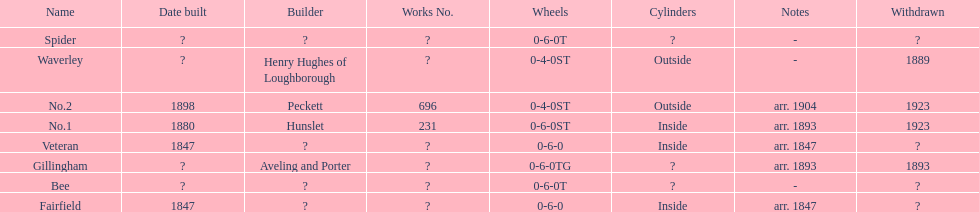What are the alderney railway names? Veteran, Fairfield, Waverley, Bee, Spider, Gillingham, No.1, No.2. When was the farfield built? 1847. What else was built that year? Veteran. 